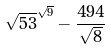Convert formula to latex. <formula><loc_0><loc_0><loc_500><loc_500>\sqrt { 5 3 } ^ { \sqrt { 9 } } - \frac { 4 9 4 } { \sqrt { 8 } }</formula> 